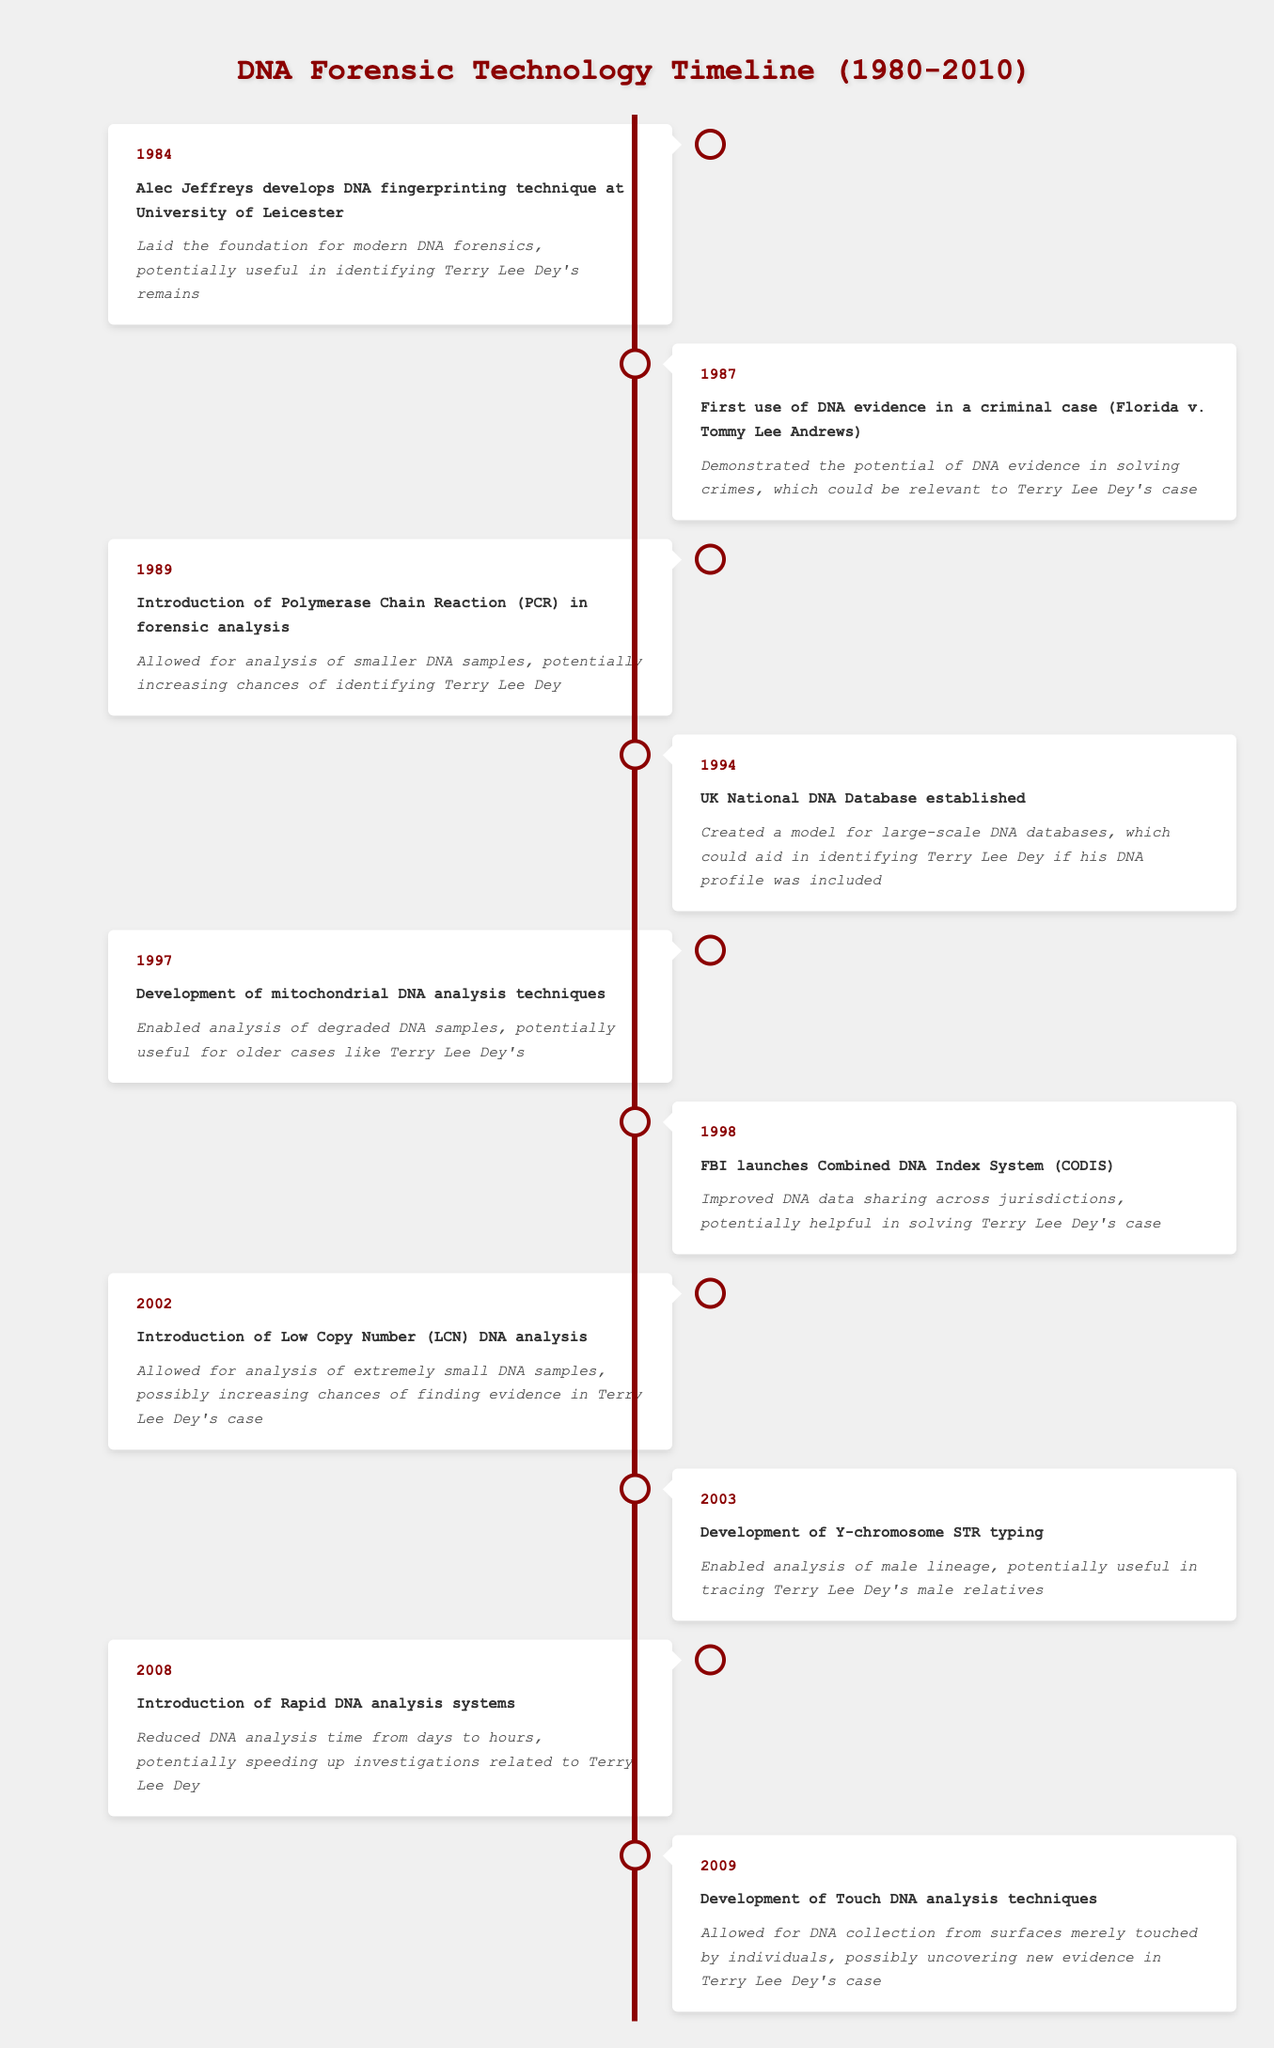What year was the DNA fingerprinting technique developed? According to the table, the DNA fingerprinting technique was developed in 1984.
Answer: 1984 Which event in the timeline represents the first use of DNA evidence in a criminal case? The first use of DNA evidence in a criminal case is represented by the event in 1987: Florida v. Tommy Lee Andrews.
Answer: Florida v. Tommy Lee Andrews How many years passed between the introduction of PCR and the establishment of the UK National DNA Database? The introduction of PCR occurred in 1989, and the UK National DNA Database was established in 1994. Therefore, the difference in years is 1994 - 1989 = 5 years.
Answer: 5 years Was mitochondrial DNA analysis developed before or after the launch of CODIS? Mitochondrial DNA analysis techniques were developed in 1997, and CODIS was launched in 1998. Since 1997 comes before 1998, it can be established that mitochondrial DNA analysis was developed before the launch of CODIS.
Answer: Before What is the significance of the introduction of Low Copy Number DNA analysis? The introduction of Low Copy Number DNA analysis in 2002 allowed for the analysis of extremely small DNA samples. This capability increases the chances of finding evidence in cases like Terry Lee Dey's.
Answer: It allows analysis of extremely small DNA samples Considering all the events, which significance mentions aiding in identifying Terry Lee Dey? The significance that explicitly mentions aiding in identifying Terry Lee Dey is found in events such as the development of DNA fingerprinting in 1984, the establishment of the UK National DNA Database in 1994, and the introduction of Low Copy Number DNA analysis in 2002.
Answer: Multiple events What was the impact of introducing Rapid DNA analysis systems in 2008? The introduction of Rapid DNA analysis systems reduced the DNA analysis time from days to hours. This significant reduction could speed up investigations related to Terry Lee Dey.
Answer: Reduced analysis time to hours How did the development of Touch DNA analysis techniques in 2009 potentially impact Terry Lee Dey's case? The development of Touch DNA analysis techniques enabled DNA collection from surfaces merely touched by individuals, which could potentially uncover new evidence in Terry Lee Dey's case.
Answer: It could uncover new evidence 